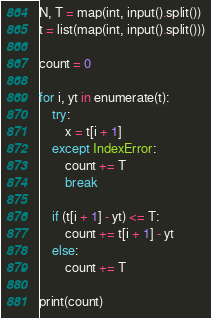<code> <loc_0><loc_0><loc_500><loc_500><_Python_>N, T = map(int, input().split())
t = list(map(int, input().split()))

count = 0

for i, yt in enumerate(t):
    try:
        x = t[i + 1]
    except IndexError:
        count += T
        break

    if (t[i + 1] - yt) <= T:
        count += t[i + 1] - yt
    else:
        count += T

print(count)</code> 